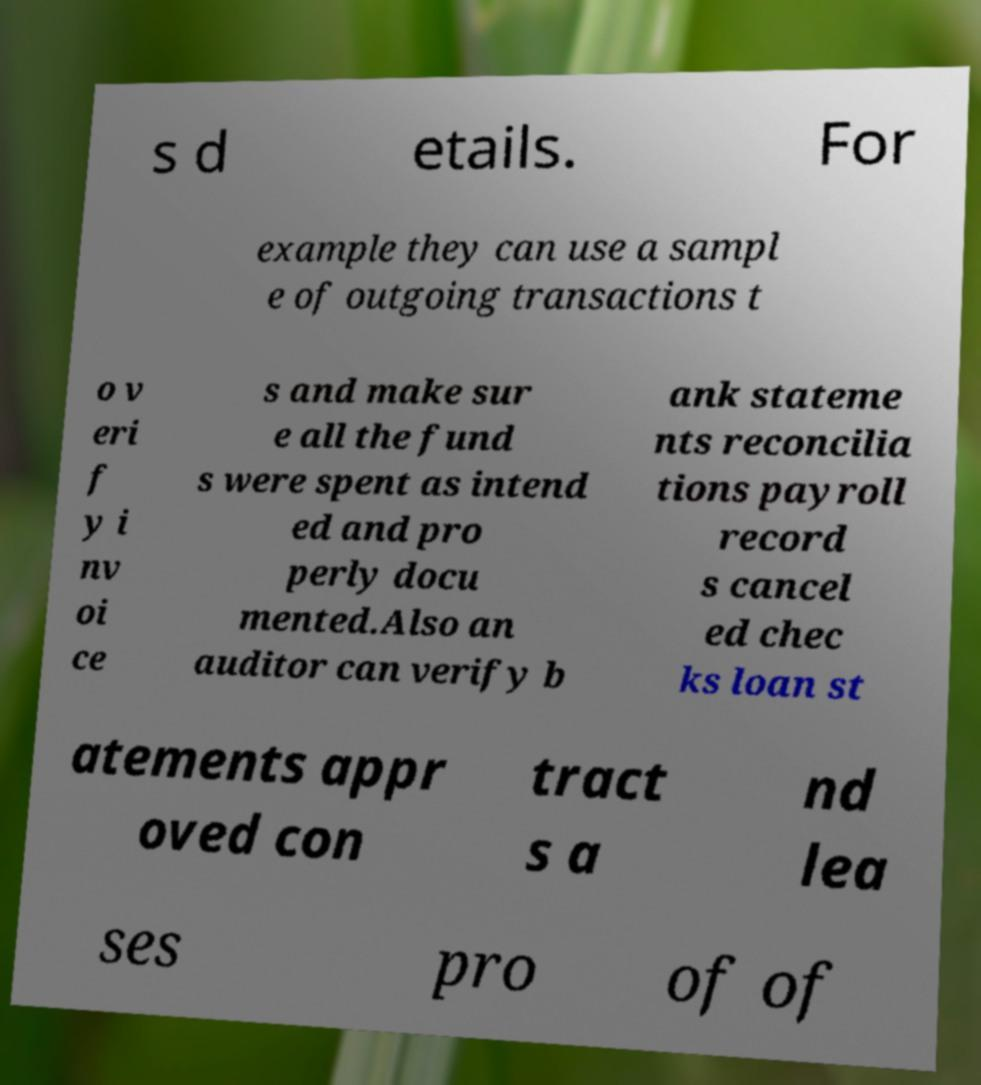Could you extract and type out the text from this image? s d etails. For example they can use a sampl e of outgoing transactions t o v eri f y i nv oi ce s and make sur e all the fund s were spent as intend ed and pro perly docu mented.Also an auditor can verify b ank stateme nts reconcilia tions payroll record s cancel ed chec ks loan st atements appr oved con tract s a nd lea ses pro of of 